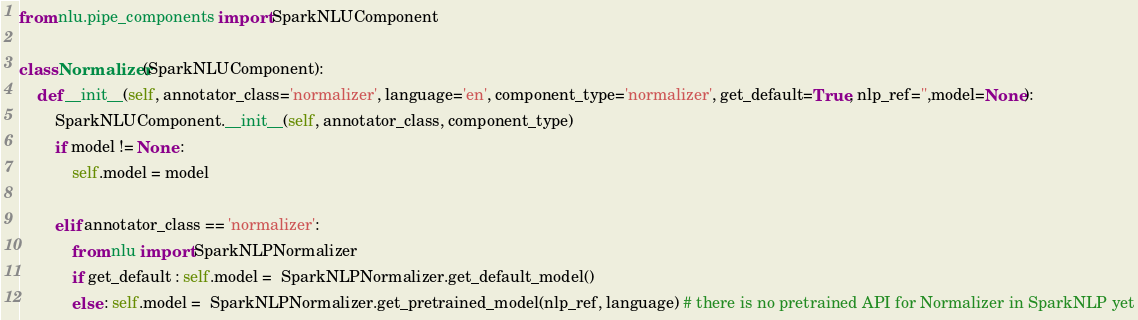Convert code to text. <code><loc_0><loc_0><loc_500><loc_500><_Python_>from nlu.pipe_components import SparkNLUComponent

class Normalizer(SparkNLUComponent):
    def __init__(self, annotator_class='normalizer', language='en', component_type='normalizer', get_default=True, nlp_ref='',model=None):
        SparkNLUComponent.__init__(self, annotator_class, component_type)
        if model != None :
            self.model = model

        elif annotator_class == 'normalizer':
            from nlu import SparkNLPNormalizer
            if get_default : self.model =  SparkNLPNormalizer.get_default_model()
            else : self.model =  SparkNLPNormalizer.get_pretrained_model(nlp_ref, language) # there is no pretrained API for Normalizer in SparkNLP yet</code> 